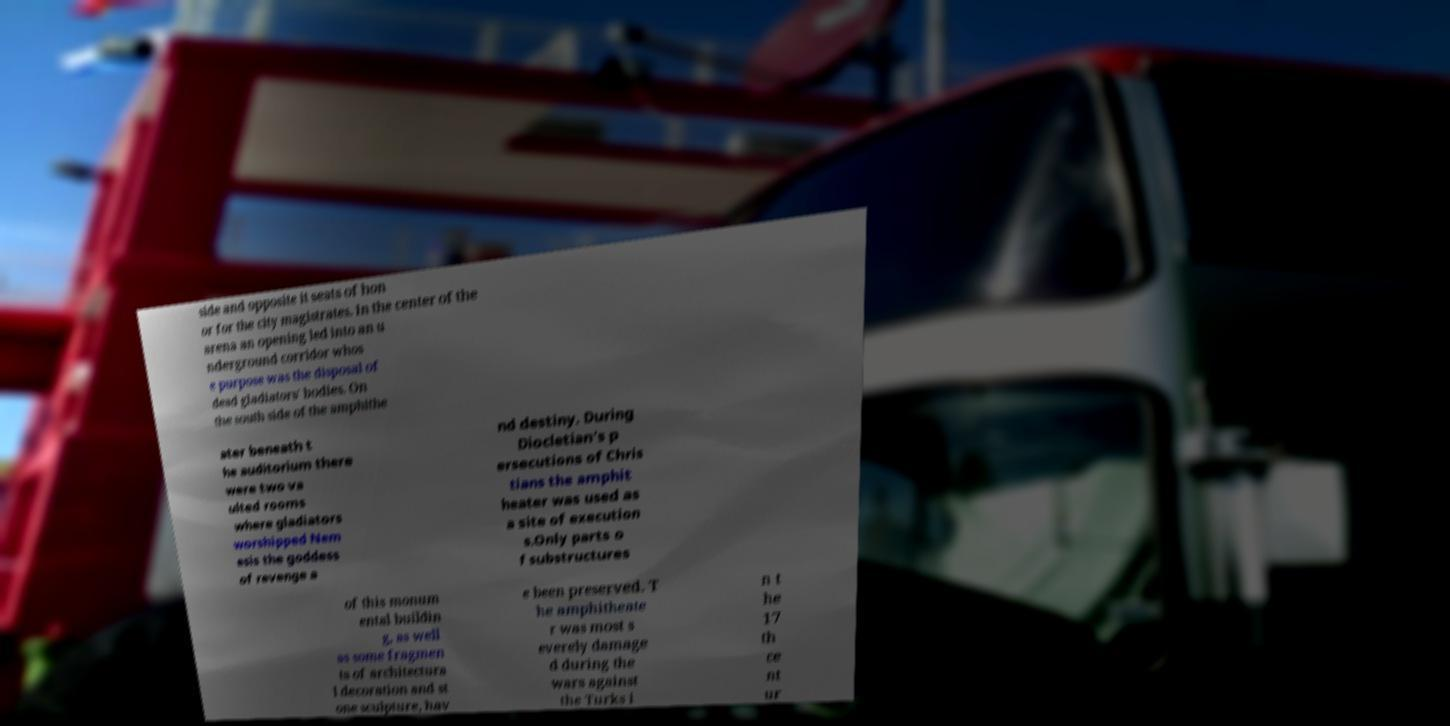Could you assist in decoding the text presented in this image and type it out clearly? side and opposite it seats of hon or for the city magistrates. In the center of the arena an opening led into an u nderground corridor whos e purpose was the disposal of dead gladiators' bodies. On the south side of the amphithe ater beneath t he auditorium there were two va ulted rooms where gladiators worshipped Nem esis the goddess of revenge a nd destiny. During Diocletian's p ersecutions of Chris tians the amphit heater was used as a site of execution s.Only parts o f substructures of this monum ental buildin g, as well as some fragmen ts of architectura l decoration and st one sculpture, hav e been preserved. T he amphitheate r was most s everely damage d during the wars against the Turks i n t he 17 th ce nt ur 